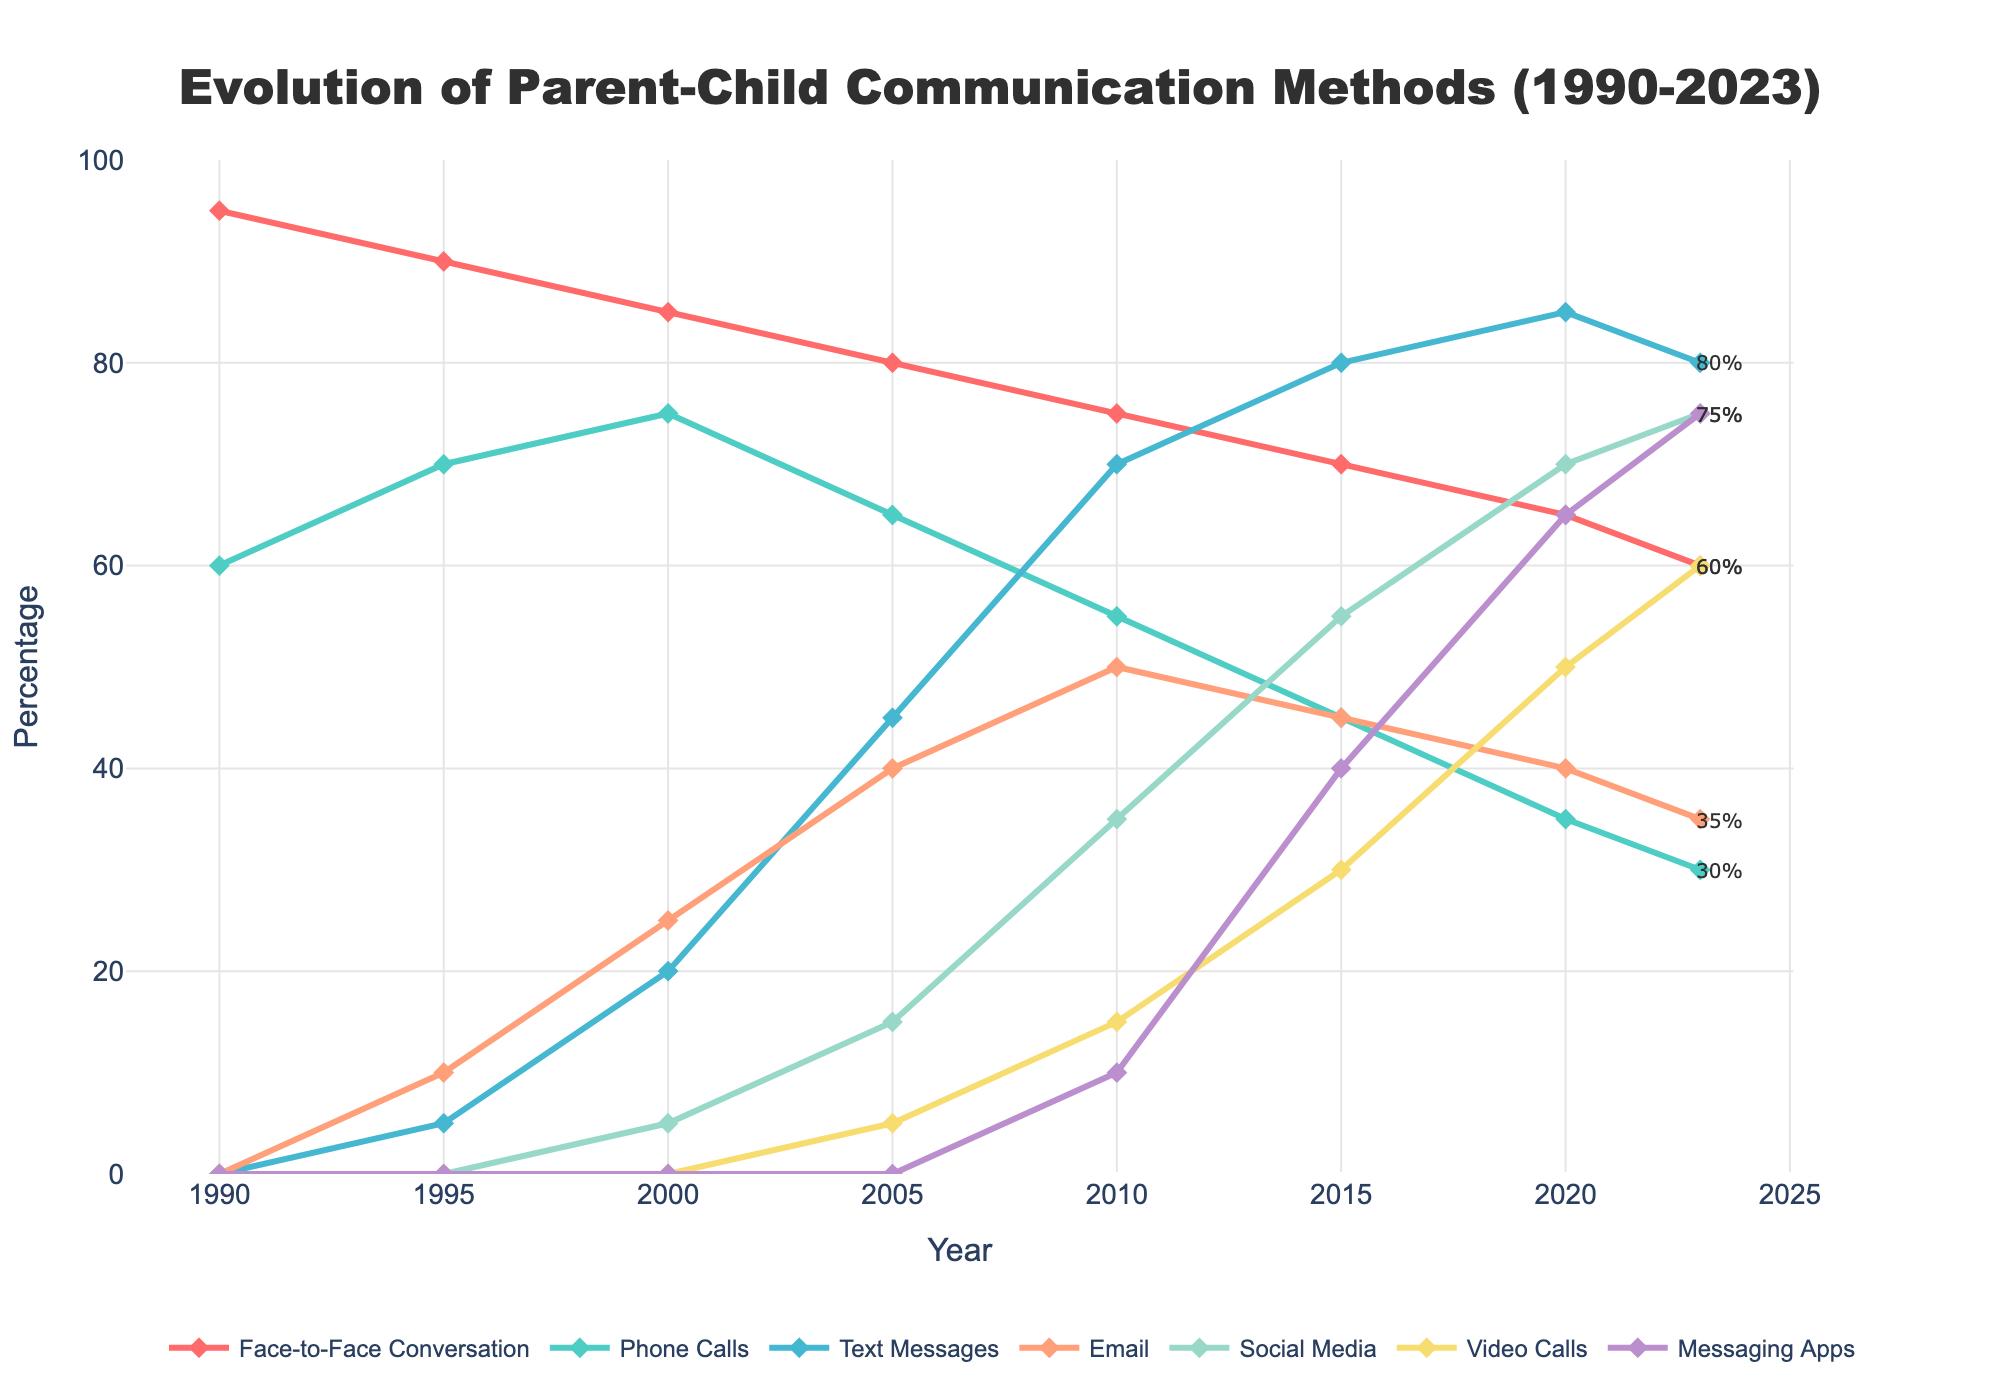What are the two most common communication methods in 2023? By observing the last data points for each communication method in the figure, Social Media (75%) and Messaging Apps (75%) are the most common in 2023.
Answer: Social Media and Messaging Apps How has the use of Face-to-Face Conversation changed from 1990 to 2023? By comparing the first and last data points for Face-to-Face Conversation, it decreases from 95% in 1990 to 60% in 2023.
Answer: Decreased by 35% Which communication method saw the highest increase between 1990 and 2023? By examining the first and last data points for all methods, Text Messages show the highest increase, from 0% in 1990 to 80% in 2023, a 80% increase.
Answer: Text Messages In which year did Video Calls surpass 50% usage? By checking the data points for Video Calls, it surpasses 50% in the year 2020 (50%) and is higher in 2023 (60%).
Answer: 2020 How did the usage of Phone Calls change from 1995 to 2023? By observing the data points for Phone Calls in 1995 (70%) and 2023 (30%), the usage decreased.
Answer: Decreased by 40% What is the combined percentage of Text Messages and Messaging Apps usage in 2020? The data points show Text Messages at 85% and Messaging Apps at 65% in 2020. Summing these gives 85% + 65% = 150%.
Answer: 150% Which communication methods had over 70% usage in 2023? By inspecting the last data points for each method in the figure, Text Messages (80%), Social Media (75%), and Messaging Apps (75%) had over 70% usage.
Answer: Text Messages, Social Media, Messaging Apps What visual pattern do you notice about the usage trend of Email from 2000 to 2023? By noting the peaks and declines in the Email line, it rises steadily until 2010 (50%) and then declines to 35% in 2023.
Answer: Rise then fall In which year did Face-to-Face Conversation and Phone Calls have the same usage percentage? By comparing the data points, Face-to-Face Conversation and Phone Calls had the same usage of 65% in 2005.
Answer: 2005 